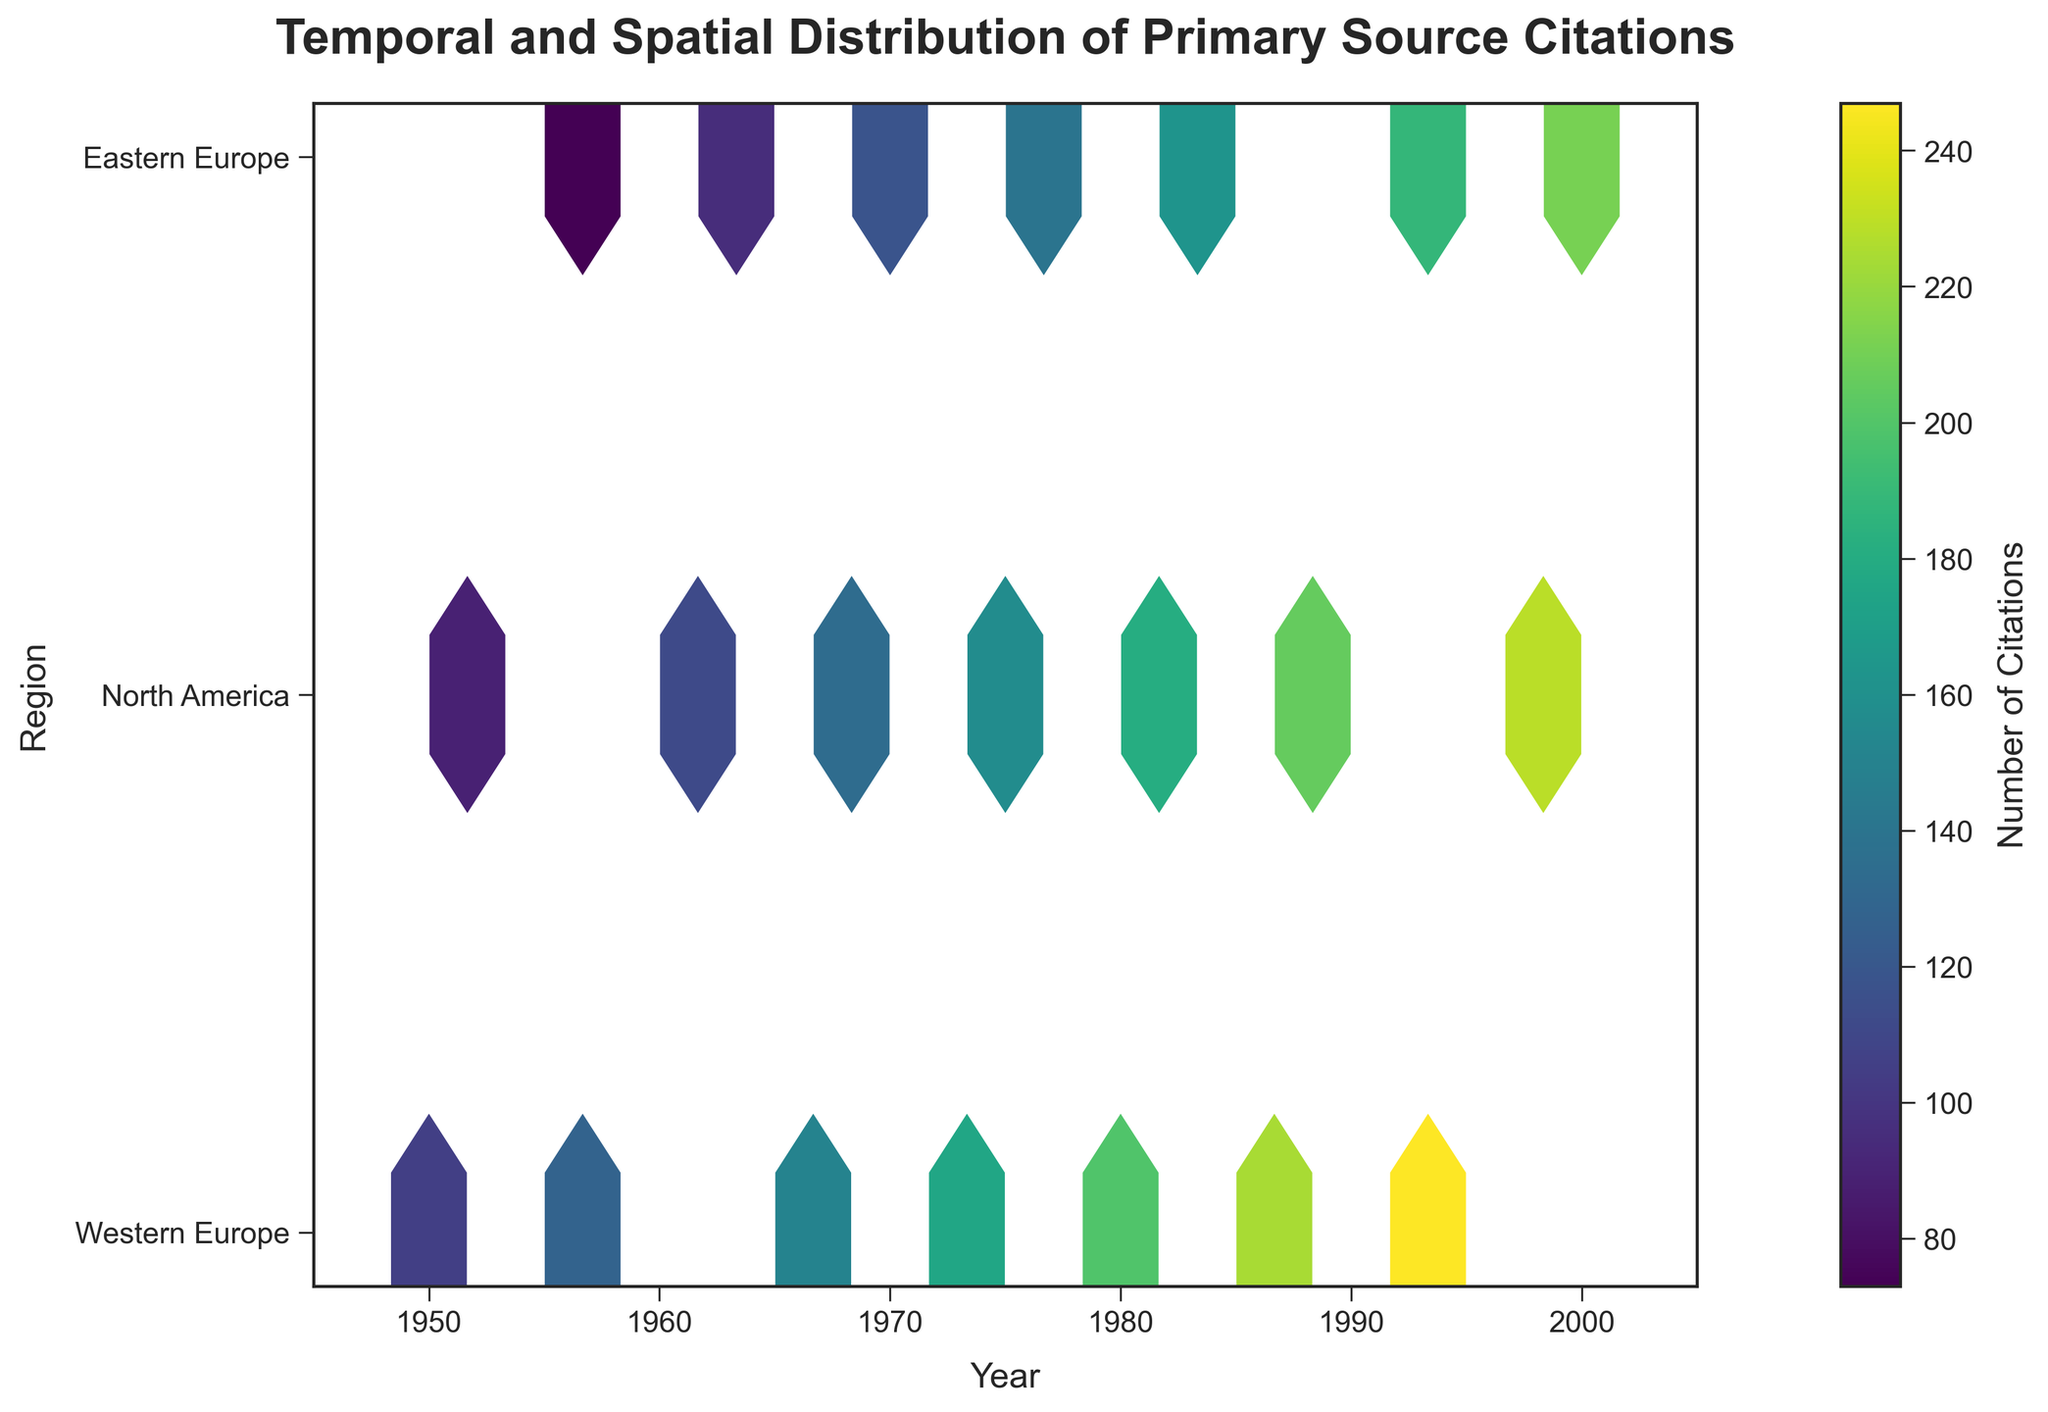What is the title of the plot? The title is located at the top of the plot and typically describes the content. In this case, it is "Temporal and Spatial Distribution of Primary Source Citations."
Answer: Temporal and Spatial Distribution of Primary Source Citations Between which years is the data on the x-axis distributed? The x-axis, representing the years, covers a range from 1945 to 2005, as indicated by the x-axis limits.
Answer: 1945 to 2005 Which region has the highest citation count in the hexbin plot? Western Europe appears to have consistently high citation counts as indicated by darker hexagon bins and the color map representing citation numbers.
Answer: Western Europe How many regions are represented on the y-axis? By looking at the y-axis, there are three tick marks labeled as Western Europe, North America, and Eastern Europe.
Answer: 3 What does the color gradient in the hexbin plot represent? The color gradient represents the number of citations, with the color bar indicating that darker colors correspond to higher numbers of citations.
Answer: Number of citations Which year and region combination had the highest number of citations? By examining the darkest hexagon in the hexbin plot, one can determine the year and region combination with the highest citation count. The plot shows that Western Europe around 1995 has the darkest hexbin.
Answer: Western Europe, 1995 Are there any periods where North America had a higher citation count than Eastern Europe? If so, when? By comparing the color intensity between North America and Eastern Europe over time, the darkest hexagons in North America appear around 1990-1997, which are darker than the corresponding periods in Eastern Europe.
Answer: Yes, around 1990-1997 What is the range of citation counts in this dataset? By looking at the color bar on the right side, it shows a range from the lightest to the darkest color that corresponds to the citation counts, spanning from the minimum to the maximum values reported in the dataset.
Answer: 73 to 247 How does the distribution of citations in Western Europe compare to that in Eastern Europe? Comparing the density and color intensity of hexagons between the two regions, it can be seen that Western Europe has consistently higher citation counts (darker hexagons) compared to Eastern Europe over time.
Answer: Western Europe has higher citation counts Which decade showed the most significant increase in citations across all regions? By comparing the density of darker hexagon bins across decades, it appears that the 1980s to 1990s show the most significant increase in citation counts across Western Europe, North America, and Eastern Europe.
Answer: 1980s to 1990s 